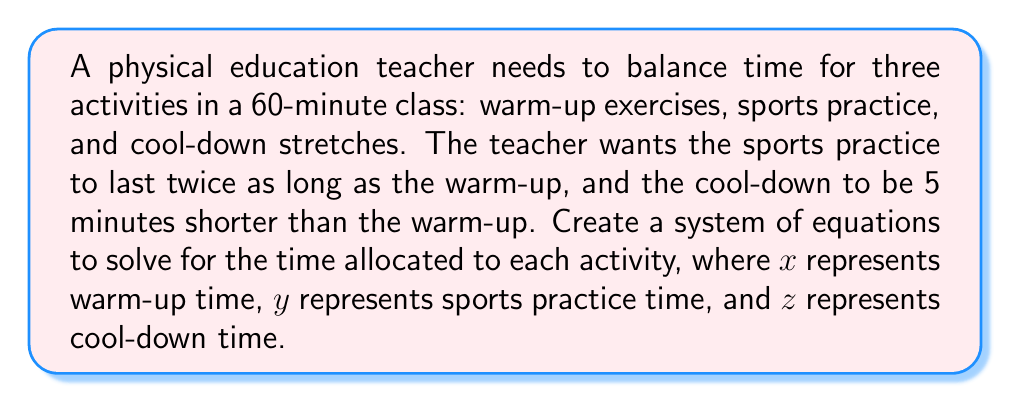Give your solution to this math problem. Let's approach this step-by-step:

1) First, we need to set up our system of equations based on the given information:

   a) The total time is 60 minutes:
      $$x + y + z = 60$$

   b) Sports practice is twice as long as warm-up:
      $$y = 2x$$

   c) Cool-down is 5 minutes shorter than warm-up:
      $$z = x - 5$$

2) Now we have a system of three equations with three unknowns:
   $$\begin{cases}
   x + y + z = 60 \\
   y = 2x \\
   z = x - 5
   \end{cases}$$

3) Let's substitute the expressions for $y$ and $z$ into the first equation:
   $$x + 2x + (x - 5) = 60$$

4) Simplify:
   $$4x - 5 = 60$$

5) Add 5 to both sides:
   $$4x = 65$$

6) Divide both sides by 4:
   $$x = 16.25$$

7) Now that we know $x$, we can find $y$ and $z$:
   $$y = 2x = 2(16.25) = 32.5$$
   $$z = x - 5 = 16.25 - 5 = 11.25$$

8) Therefore, the time allocations are:
   Warm-up (x): 16.25 minutes
   Sports practice (y): 32.5 minutes
   Cool-down (z): 11.25 minutes
Answer: $x = 16.25$, $y = 32.5$, $z = 11.25$ 